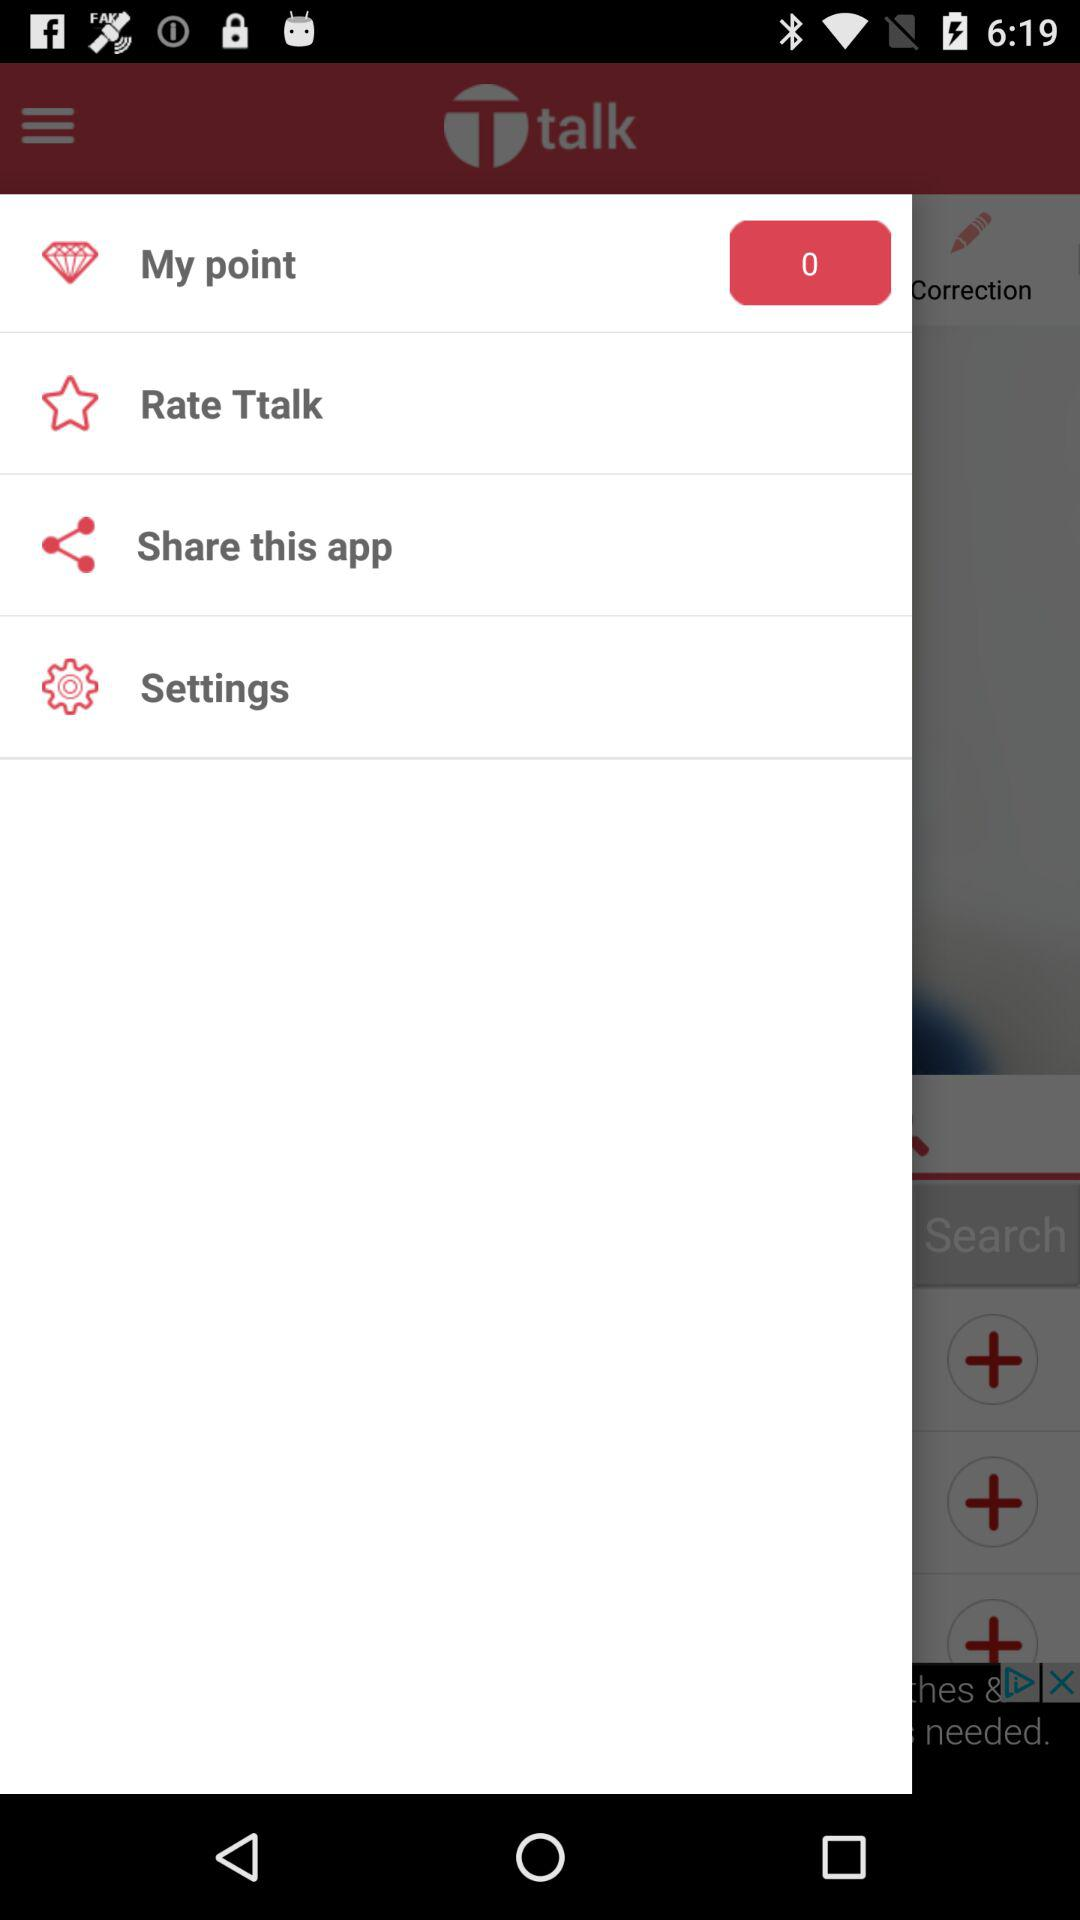How many points are shown? The shown points are 0. 